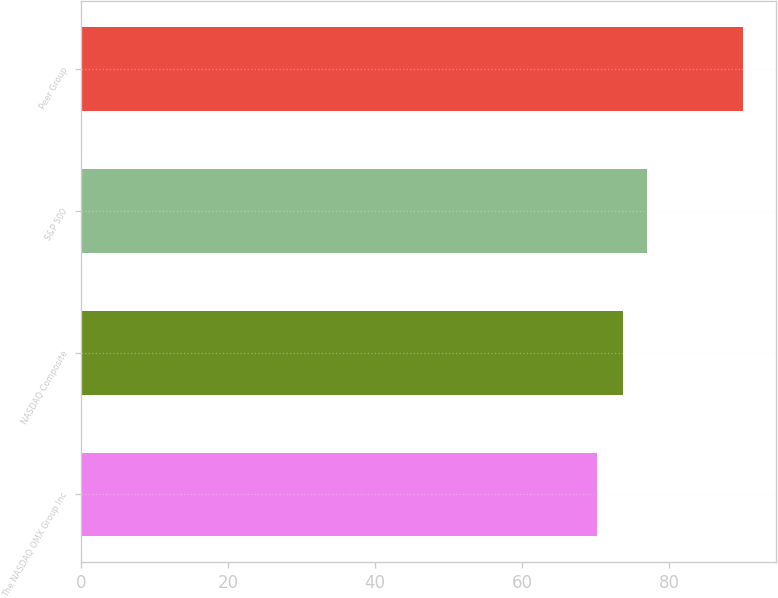Convert chart to OTSL. <chart><loc_0><loc_0><loc_500><loc_500><bar_chart><fcel>The NASDAQ OMX Group Inc<fcel>NASDAQ Composite<fcel>S&P 500<fcel>Peer Group<nl><fcel>70.24<fcel>73.77<fcel>76.96<fcel>89.99<nl></chart> 